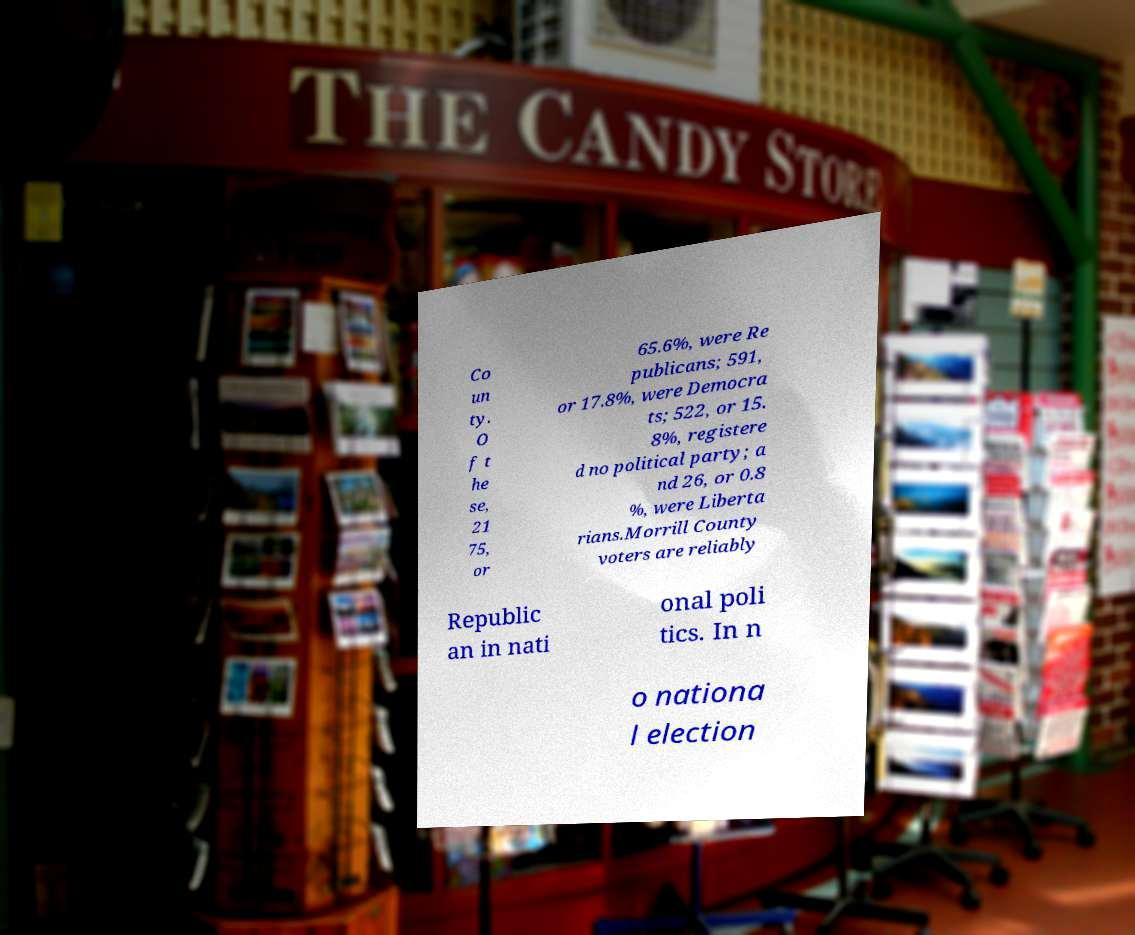What messages or text are displayed in this image? I need them in a readable, typed format. Co un ty. O f t he se, 21 75, or 65.6%, were Re publicans; 591, or 17.8%, were Democra ts; 522, or 15. 8%, registere d no political party; a nd 26, or 0.8 %, were Liberta rians.Morrill County voters are reliably Republic an in nati onal poli tics. In n o nationa l election 